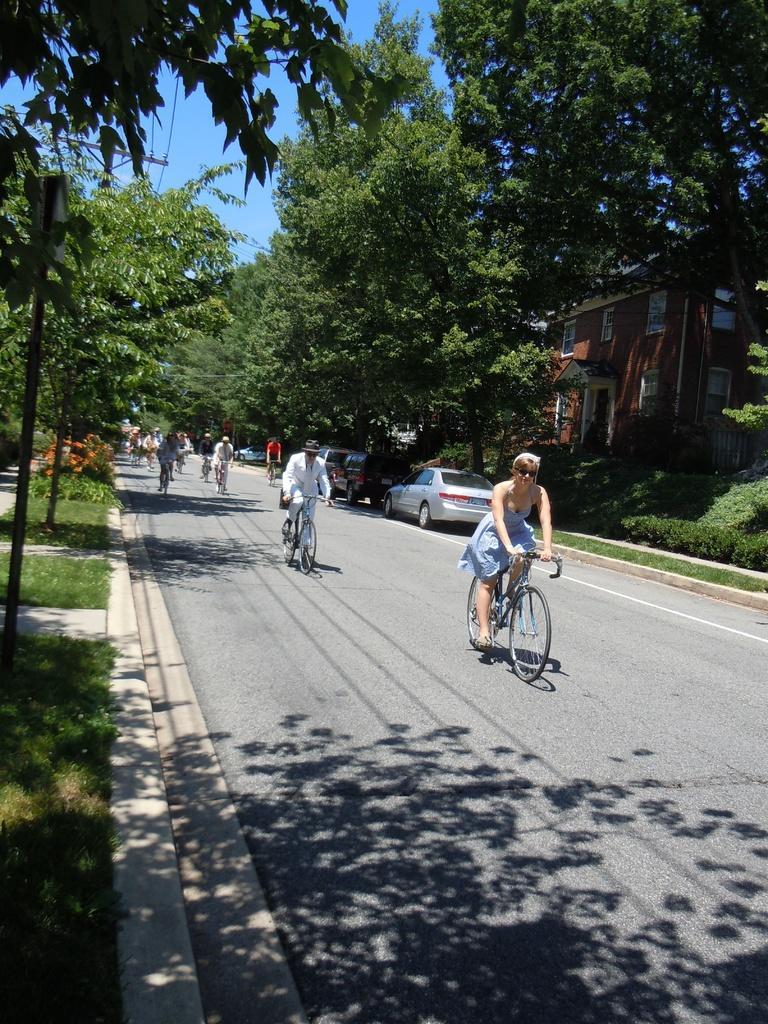Could you give a brief overview of what you see in this image? This picture shows two people riding bicycle. we see few trees and a house and couple of parked cars on the road. 